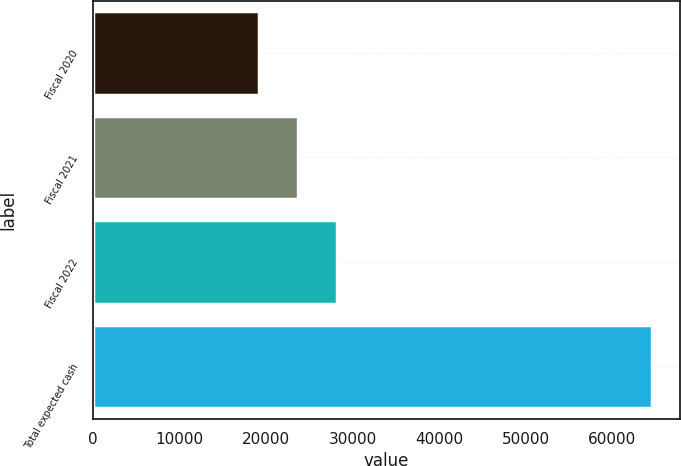Convert chart. <chart><loc_0><loc_0><loc_500><loc_500><bar_chart><fcel>Fiscal 2020<fcel>Fiscal 2021<fcel>Fiscal 2022<fcel>Total expected cash<nl><fcel>19121<fcel>23672.6<fcel>28224.2<fcel>64637<nl></chart> 